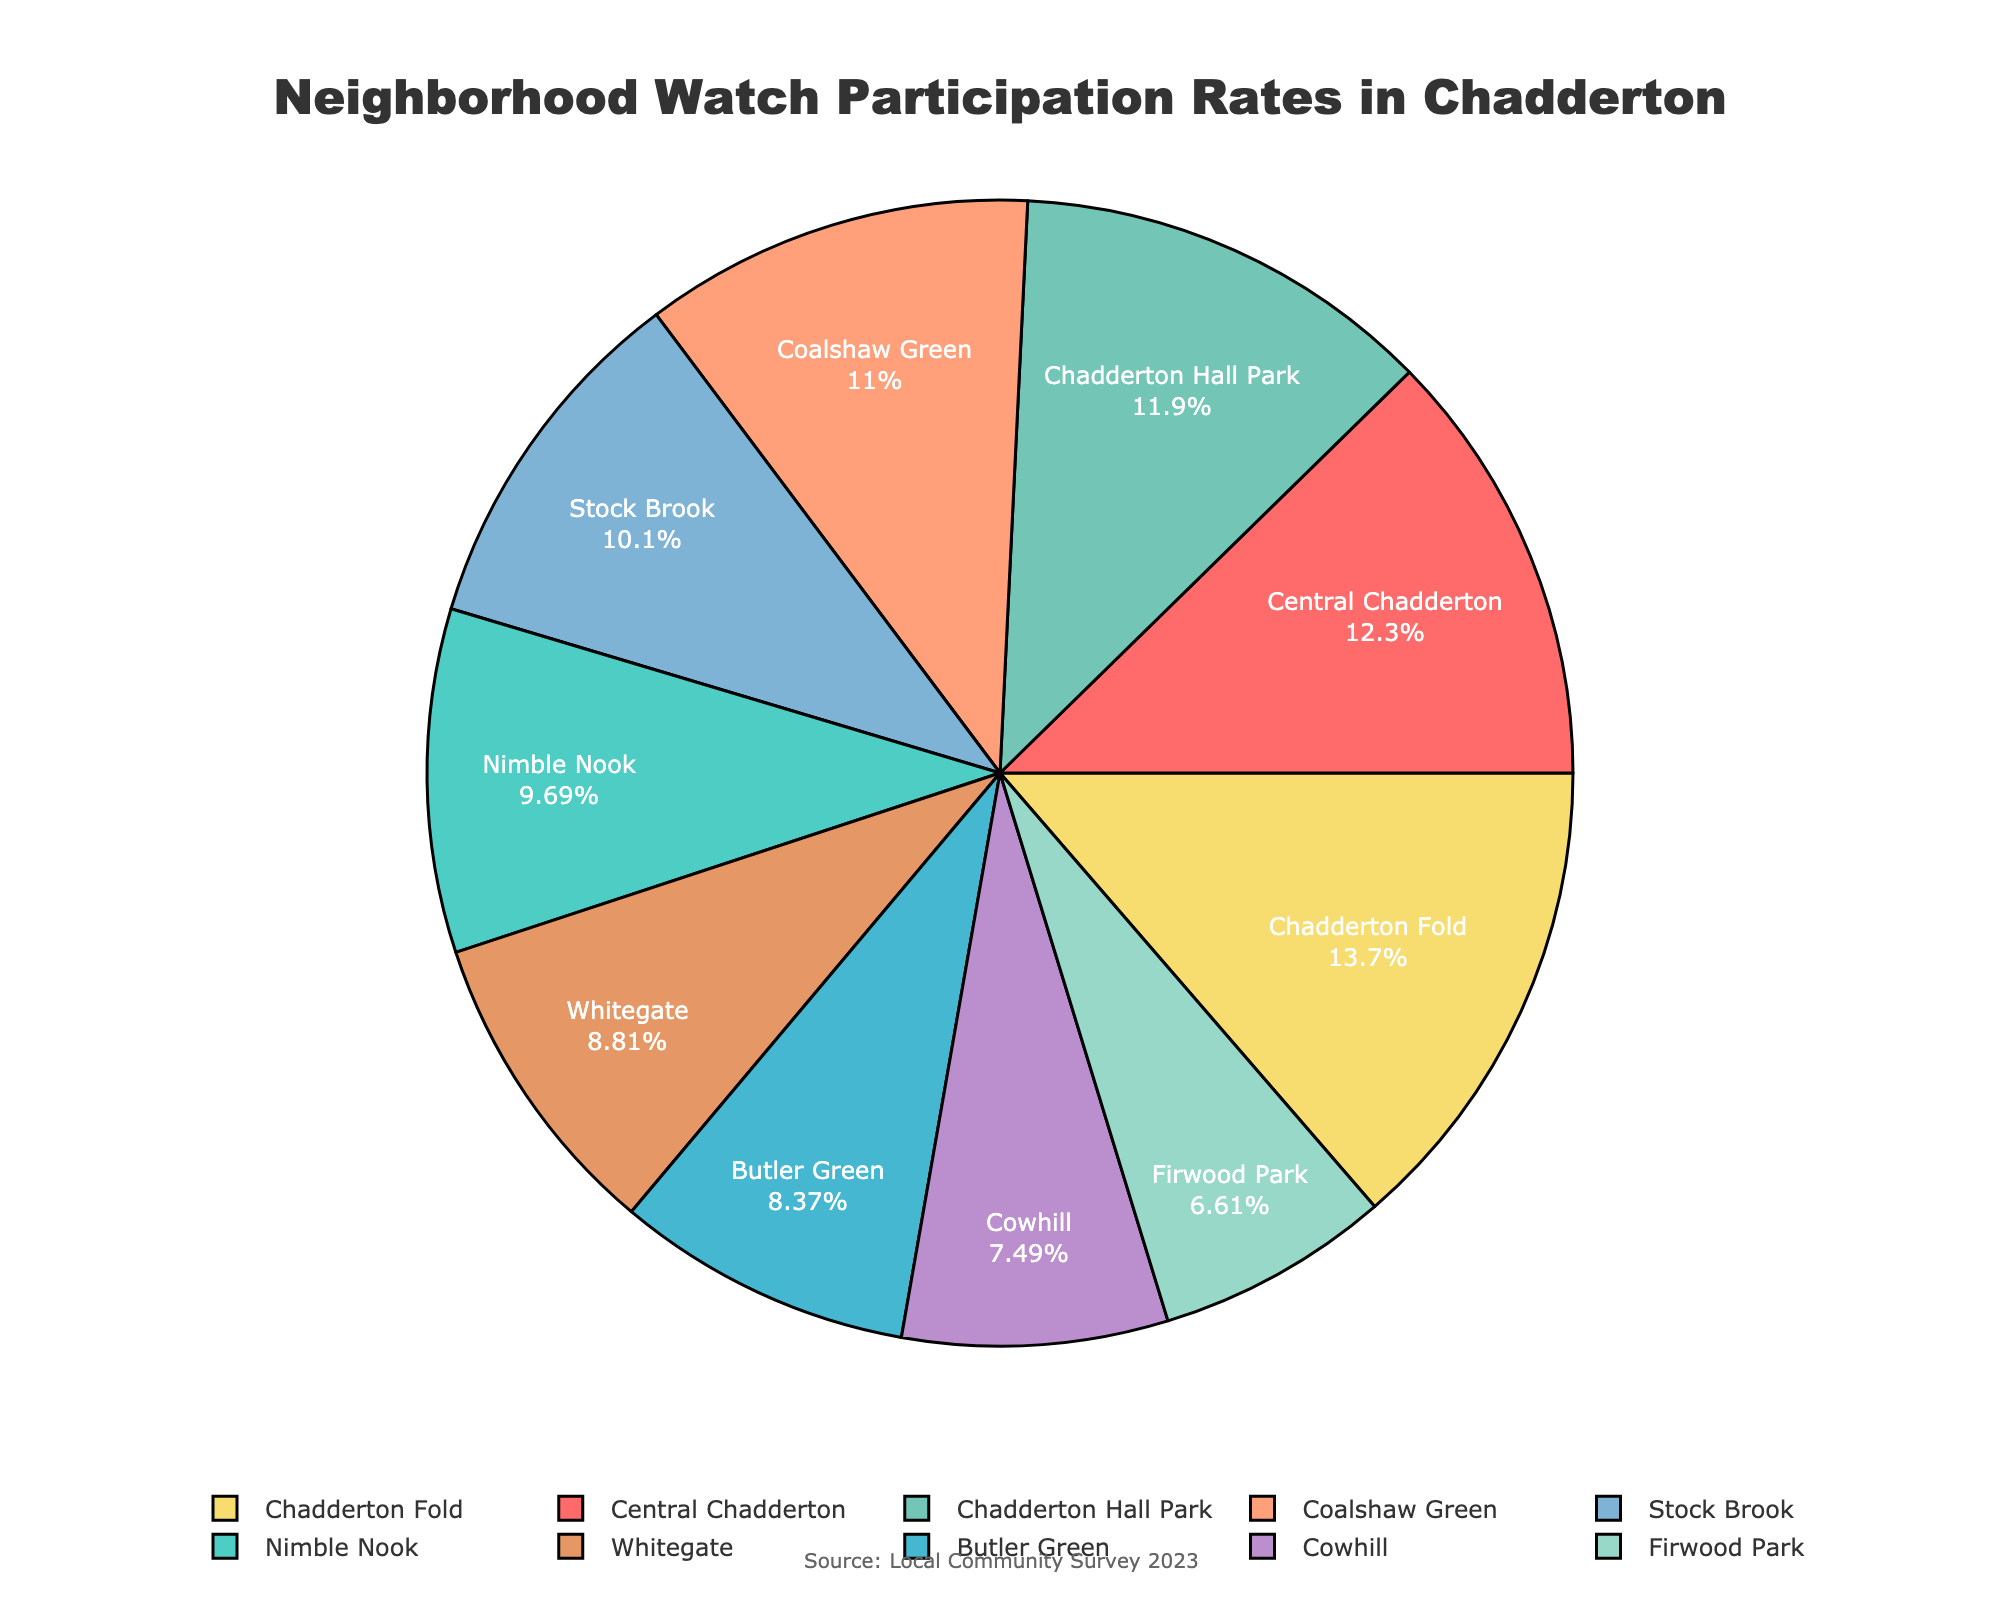What area has the highest participation rate? To determine the area with the highest participation rate, look at the pie chart and identify which slice encompasses the largest percentage of the circle. In this case, it's Chadderton Fold with a 31% participation rate.
Answer: Chadderton Fold Which area has a 17% participation rate? Examine the pie chart's labels and the corresponding participation rates. The area with a 17% participation rate is Cowhill.
Answer: Cowhill How much higher is the participation rate in Central Chadderton compared to Firwood Park? Identify the participation rates for both Central Chadderton (28%) and Firwood Park (15%). Subtract the lower rate from the higher rate: 28% - 15% = 13%.
Answer: 13% What's the total participation rate of Central Chadderton, Nimble Nook, and Butler Green combined? Find the individual participation rates for Central Chadderton (28%), Nimble Nook (22%), and Butler Green (19%). Sum these values: 28% + 22% + 19% = 69%.
Answer: 69% What percentage of participation does Stock Brook contribute to the overall participation? From the pie chart, observe Stock Brook’s participation rate, which is 23%.
Answer: 23% Which area has a lower participation rate, Whitegate or Chadderton Hall Park, and by how much? Compare the participation rates for Whitegate (20%) and Chadderton Hall Park (27%). The difference is 27% - 20% = 7%.
Answer: Whitegate by 7% What is the visual color of the section representing Coalshaw Green? Locate the section of Coalshaw Green on the pie chart and observe its color. The corresponding color is orange/salmon.
Answer: Orange/Salmon How does the combined participation rate of Cowhill and Firwood Park compare to that of Chadderton Fold? Identify the participation rates for Cowhill (17%), Firwood Park (15%), and Chadderton Fold (31%). Sum the rates for Cowhill and Firwood Park (17% + 15% = 32%) and compare it to Chadderton Fold (31%). The combined rate is higher by 1%.
Answer: Higher by 1% What percentage of the total participation is made up by the areas with less than 20% participation each? Identify the areas with participation rates less than 20%: Butler Green (19%), Firwood Park (15%), Cowhill (17%), and Whitegate (20%—technically equal, but we'll exclude it for being exactly 20%). Sum their rates: 19% + 15% + 17% = 51%.
Answer: 51% 